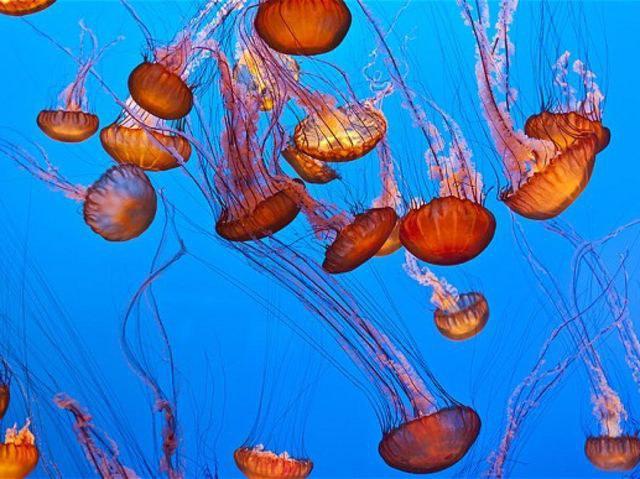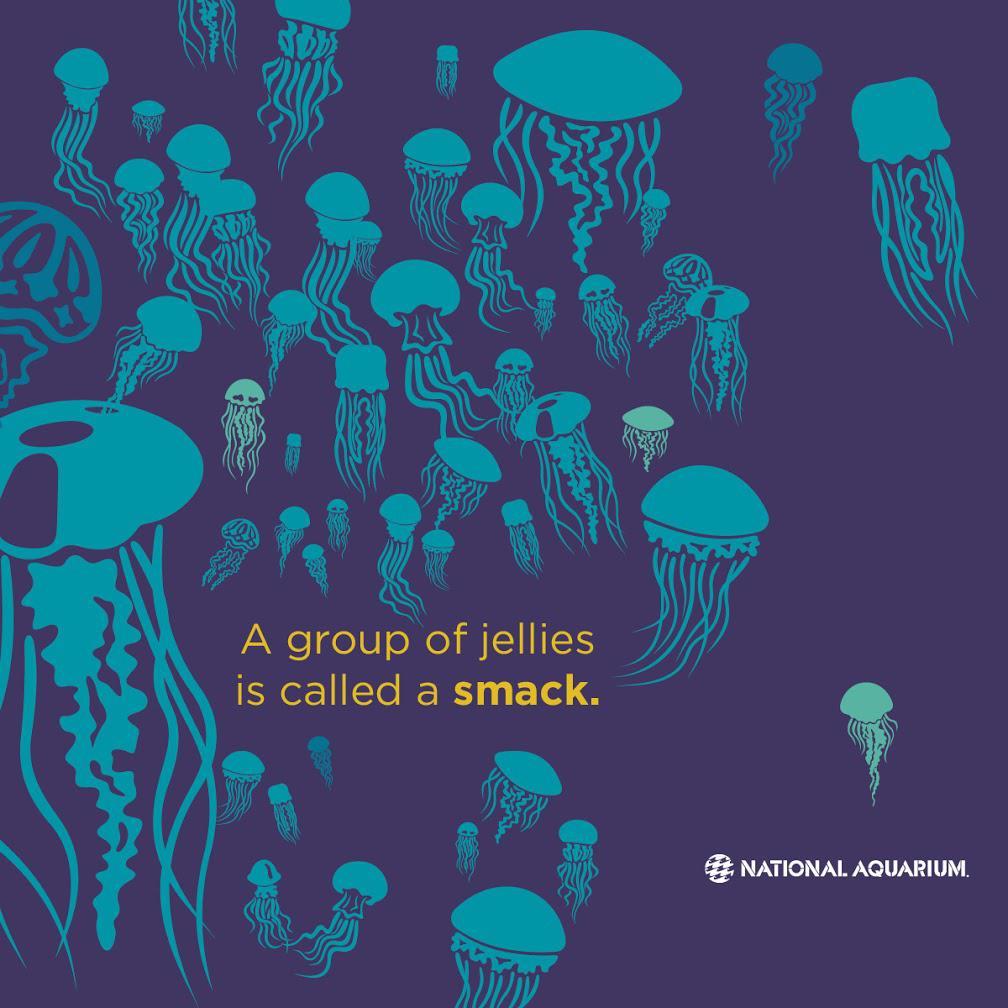The first image is the image on the left, the second image is the image on the right. Evaluate the accuracy of this statement regarding the images: "Gold colored jellyfish are swimming down.". Is it true? Answer yes or no. Yes. The first image is the image on the left, the second image is the image on the right. Evaluate the accuracy of this statement regarding the images: "An image shows at least a dozen vivid orange jellyfish, with tendrils trailing upward.". Is it true? Answer yes or no. Yes. 